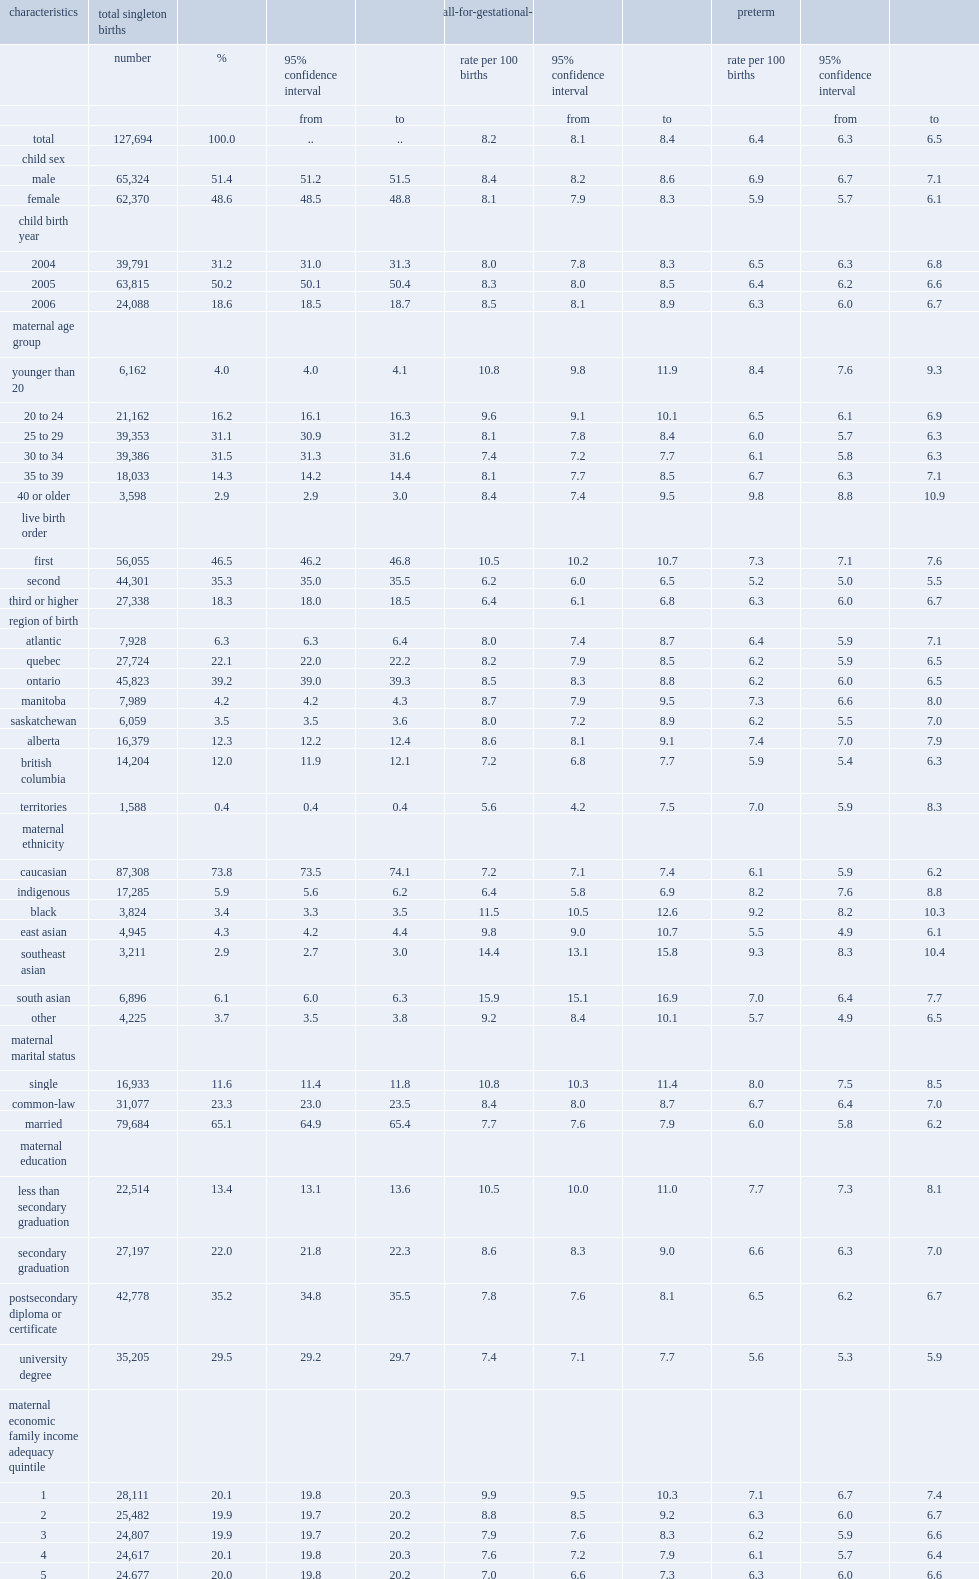What was the percentage of the overall crude rate of small-for-gestational-age birth? 8.2. What was the percentage of the overall crude rate of preterm birth? 6.4. 